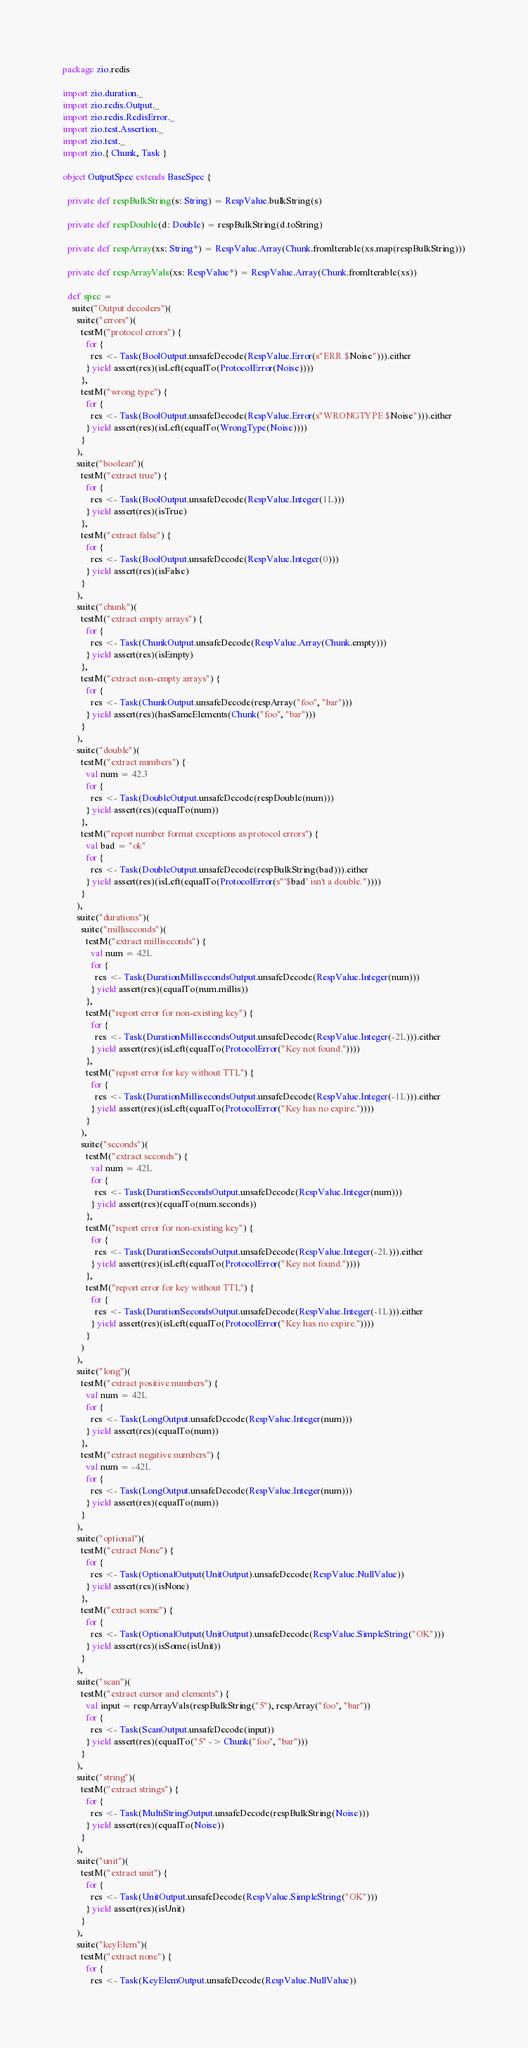<code> <loc_0><loc_0><loc_500><loc_500><_Scala_>package zio.redis

import zio.duration._
import zio.redis.Output._
import zio.redis.RedisError._
import zio.test.Assertion._
import zio.test._
import zio.{ Chunk, Task }

object OutputSpec extends BaseSpec {

  private def respBulkString(s: String) = RespValue.bulkString(s)

  private def respDouble(d: Double) = respBulkString(d.toString)

  private def respArray(xs: String*) = RespValue.Array(Chunk.fromIterable(xs.map(respBulkString)))

  private def respArrayVals(xs: RespValue*) = RespValue.Array(Chunk.fromIterable(xs))

  def spec =
    suite("Output decoders")(
      suite("errors")(
        testM("protocol errors") {
          for {
            res <- Task(BoolOutput.unsafeDecode(RespValue.Error(s"ERR $Noise"))).either
          } yield assert(res)(isLeft(equalTo(ProtocolError(Noise))))
        },
        testM("wrong type") {
          for {
            res <- Task(BoolOutput.unsafeDecode(RespValue.Error(s"WRONGTYPE $Noise"))).either
          } yield assert(res)(isLeft(equalTo(WrongType(Noise))))
        }
      ),
      suite("boolean")(
        testM("extract true") {
          for {
            res <- Task(BoolOutput.unsafeDecode(RespValue.Integer(1L)))
          } yield assert(res)(isTrue)
        },
        testM("extract false") {
          for {
            res <- Task(BoolOutput.unsafeDecode(RespValue.Integer(0)))
          } yield assert(res)(isFalse)
        }
      ),
      suite("chunk")(
        testM("extract empty arrays") {
          for {
            res <- Task(ChunkOutput.unsafeDecode(RespValue.Array(Chunk.empty)))
          } yield assert(res)(isEmpty)
        },
        testM("extract non-empty arrays") {
          for {
            res <- Task(ChunkOutput.unsafeDecode(respArray("foo", "bar")))
          } yield assert(res)(hasSameElements(Chunk("foo", "bar")))
        }
      ),
      suite("double")(
        testM("extract numbers") {
          val num = 42.3
          for {
            res <- Task(DoubleOutput.unsafeDecode(respDouble(num)))
          } yield assert(res)(equalTo(num))
        },
        testM("report number format exceptions as protocol errors") {
          val bad = "ok"
          for {
            res <- Task(DoubleOutput.unsafeDecode(respBulkString(bad))).either
          } yield assert(res)(isLeft(equalTo(ProtocolError(s"'$bad' isn't a double."))))
        }
      ),
      suite("durations")(
        suite("milliseconds")(
          testM("extract milliseconds") {
            val num = 42L
            for {
              res <- Task(DurationMillisecondsOutput.unsafeDecode(RespValue.Integer(num)))
            } yield assert(res)(equalTo(num.millis))
          },
          testM("report error for non-existing key") {
            for {
              res <- Task(DurationMillisecondsOutput.unsafeDecode(RespValue.Integer(-2L))).either
            } yield assert(res)(isLeft(equalTo(ProtocolError("Key not found."))))
          },
          testM("report error for key without TTL") {
            for {
              res <- Task(DurationMillisecondsOutput.unsafeDecode(RespValue.Integer(-1L))).either
            } yield assert(res)(isLeft(equalTo(ProtocolError("Key has no expire."))))
          }
        ),
        suite("seconds")(
          testM("extract seconds") {
            val num = 42L
            for {
              res <- Task(DurationSecondsOutput.unsafeDecode(RespValue.Integer(num)))
            } yield assert(res)(equalTo(num.seconds))
          },
          testM("report error for non-existing key") {
            for {
              res <- Task(DurationSecondsOutput.unsafeDecode(RespValue.Integer(-2L))).either
            } yield assert(res)(isLeft(equalTo(ProtocolError("Key not found."))))
          },
          testM("report error for key without TTL") {
            for {
              res <- Task(DurationSecondsOutput.unsafeDecode(RespValue.Integer(-1L))).either
            } yield assert(res)(isLeft(equalTo(ProtocolError("Key has no expire."))))
          }
        )
      ),
      suite("long")(
        testM("extract positive numbers") {
          val num = 42L
          for {
            res <- Task(LongOutput.unsafeDecode(RespValue.Integer(num)))
          } yield assert(res)(equalTo(num))
        },
        testM("extract negative numbers") {
          val num = -42L
          for {
            res <- Task(LongOutput.unsafeDecode(RespValue.Integer(num)))
          } yield assert(res)(equalTo(num))
        }
      ),
      suite("optional")(
        testM("extract None") {
          for {
            res <- Task(OptionalOutput(UnitOutput).unsafeDecode(RespValue.NullValue))
          } yield assert(res)(isNone)
        },
        testM("extract some") {
          for {
            res <- Task(OptionalOutput(UnitOutput).unsafeDecode(RespValue.SimpleString("OK")))
          } yield assert(res)(isSome(isUnit))
        }
      ),
      suite("scan")(
        testM("extract cursor and elements") {
          val input = respArrayVals(respBulkString("5"), respArray("foo", "bar"))
          for {
            res <- Task(ScanOutput.unsafeDecode(input))
          } yield assert(res)(equalTo("5" -> Chunk("foo", "bar")))
        }
      ),
      suite("string")(
        testM("extract strings") {
          for {
            res <- Task(MultiStringOutput.unsafeDecode(respBulkString(Noise)))
          } yield assert(res)(equalTo(Noise))
        }
      ),
      suite("unit")(
        testM("extract unit") {
          for {
            res <- Task(UnitOutput.unsafeDecode(RespValue.SimpleString("OK")))
          } yield assert(res)(isUnit)
        }
      ),
      suite("keyElem")(
        testM("extract none") {
          for {
            res <- Task(KeyElemOutput.unsafeDecode(RespValue.NullValue))</code> 